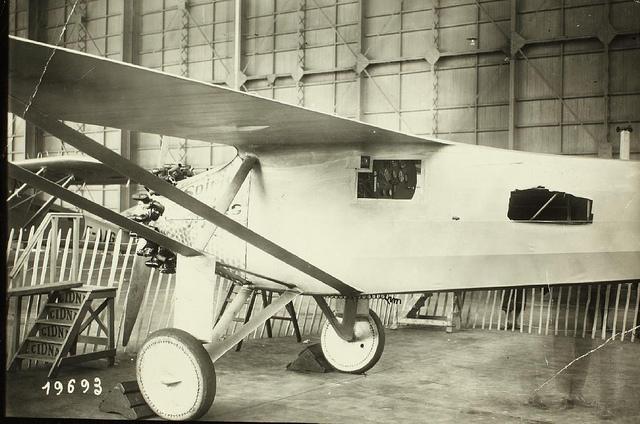What kind of plane is this?
Be succinct. Single engine. What is the plane for?
Give a very brief answer. Flying. What year was this photo taken?
Keep it brief. 1969. 